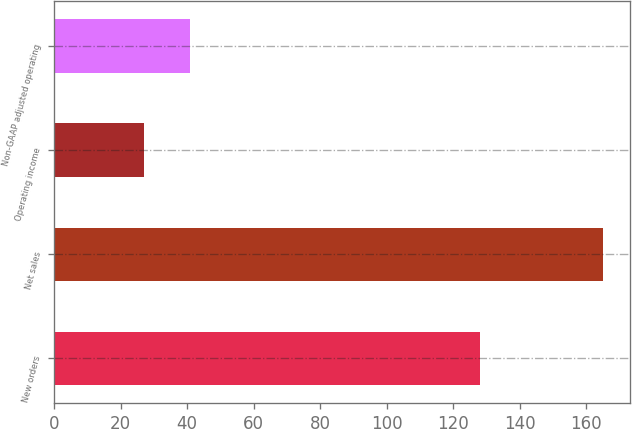Convert chart. <chart><loc_0><loc_0><loc_500><loc_500><bar_chart><fcel>New orders<fcel>Net sales<fcel>Operating income<fcel>Non-GAAP adjusted operating<nl><fcel>128<fcel>165<fcel>27<fcel>40.8<nl></chart> 